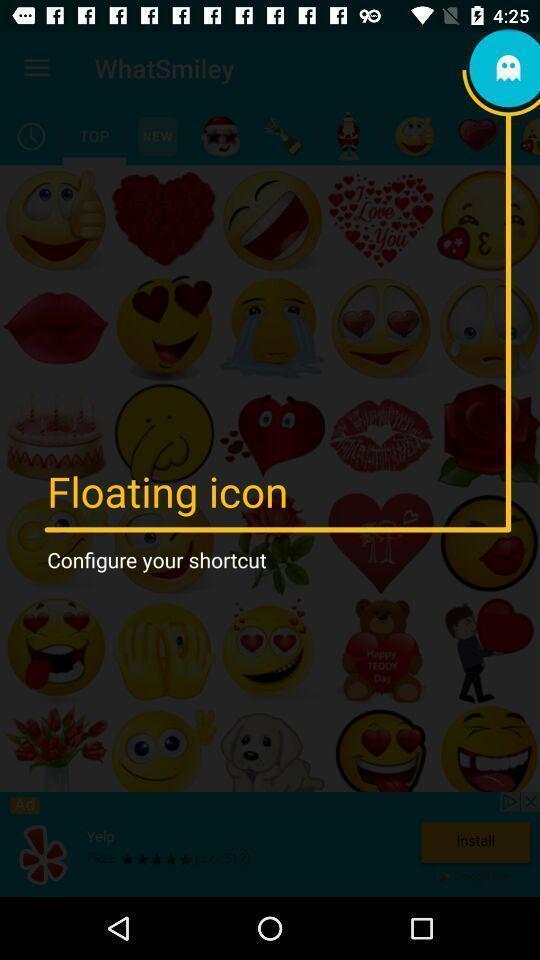Provide a detailed account of this screenshot. Popup of an emoji in the app to use. 